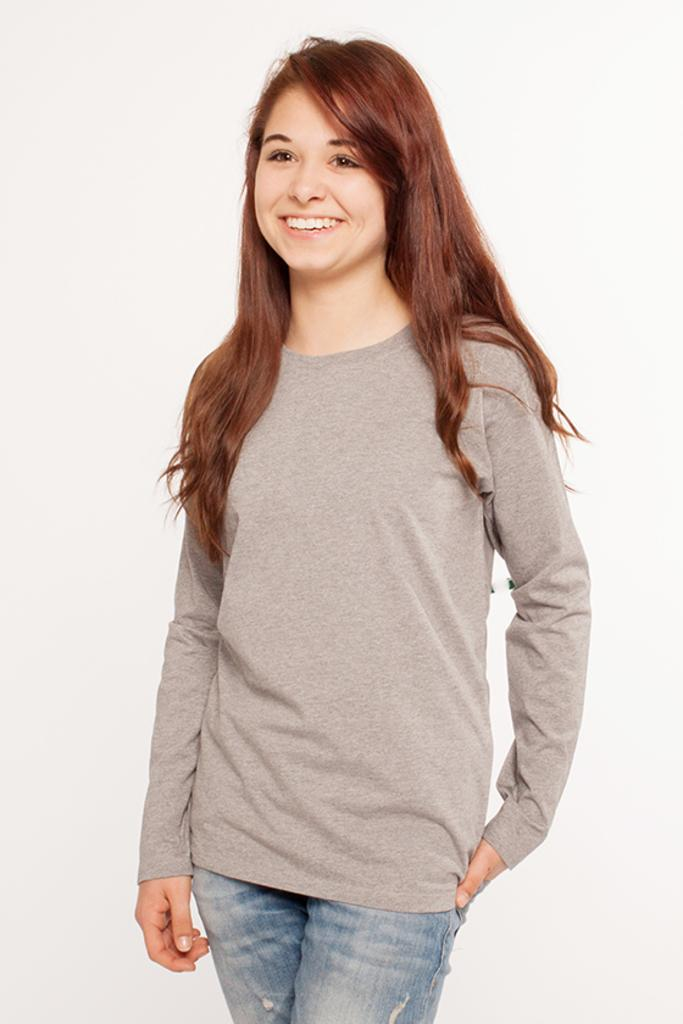What is the main subject of the image? The main subject of the image is a woman. What is the woman doing in the image? The woman is standing in the image. What expression does the woman have? The woman is smiling in the image. What type of donkey can be seen in the image? There is no donkey present in the image. What liquid is being used by the woman in the image? There is no liquid being used by the woman in the image. 